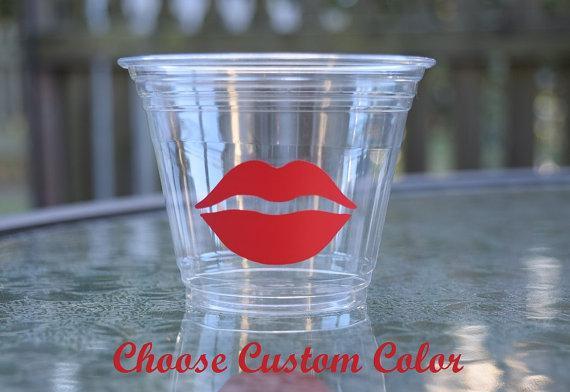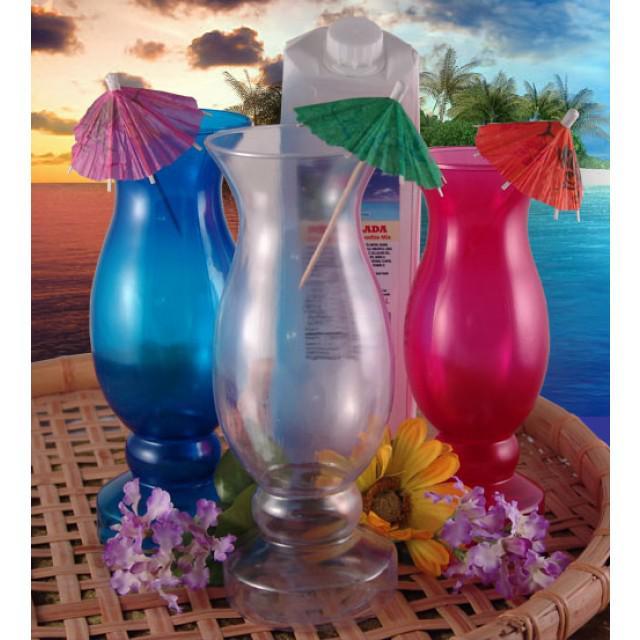The first image is the image on the left, the second image is the image on the right. Evaluate the accuracy of this statement regarding the images: "Some containers are empty.". Is it true? Answer yes or no. Yes. The first image is the image on the left, the second image is the image on the right. Given the left and right images, does the statement "There are no more than 2 cups in the left image, and they are all plastic." hold true? Answer yes or no. Yes. 